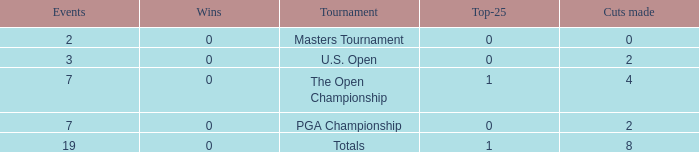What is the Wins of the Top-25 of 1 and 7 Events? 0.0. 